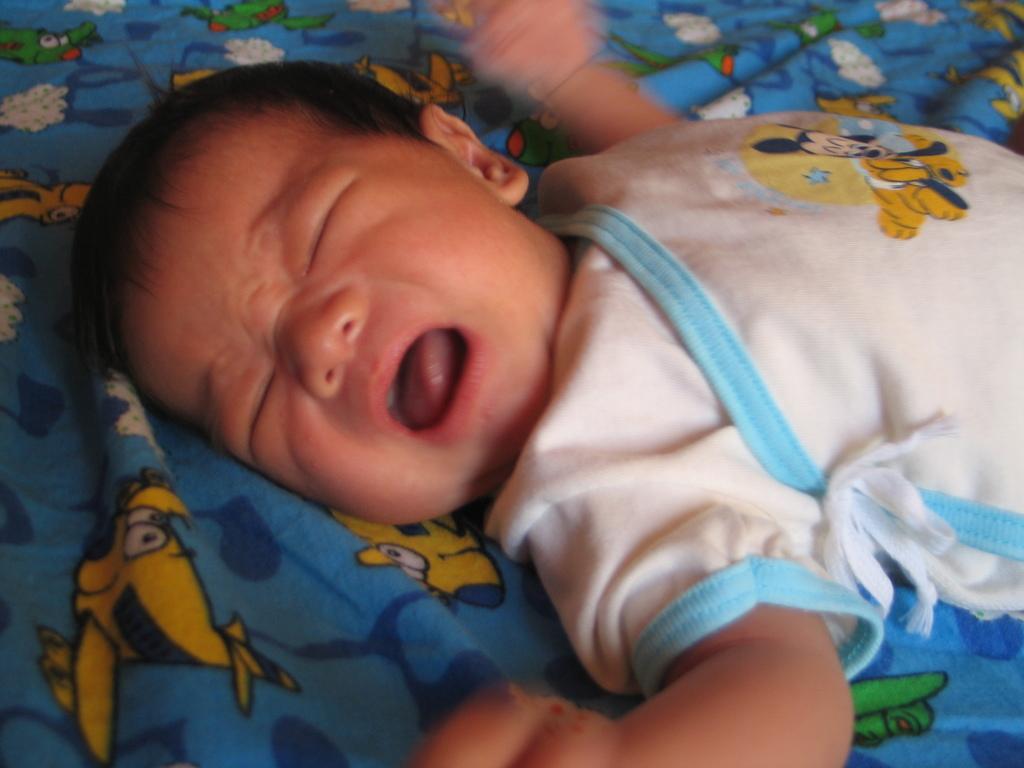In one or two sentences, can you explain what this image depicts? In this image we can see a baby lying on a cloth with animated characters. 